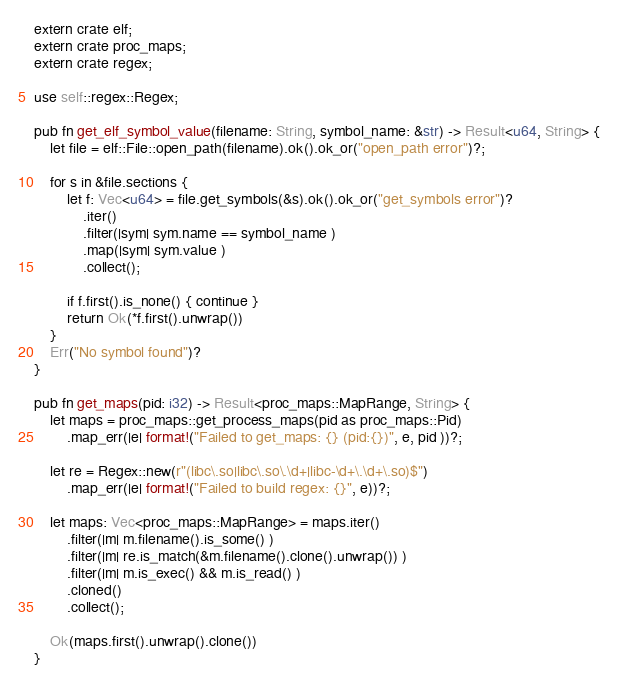<code> <loc_0><loc_0><loc_500><loc_500><_Rust_>extern crate elf;
extern crate proc_maps;
extern crate regex;

use self::regex::Regex;

pub fn get_elf_symbol_value(filename: String, symbol_name: &str) -> Result<u64, String> {
    let file = elf::File::open_path(filename).ok().ok_or("open_path error")?;

    for s in &file.sections {
        let f: Vec<u64> = file.get_symbols(&s).ok().ok_or("get_symbols error")?
            .iter()
            .filter(|sym| sym.name == symbol_name )
            .map(|sym| sym.value )
            .collect();

        if f.first().is_none() { continue }
        return Ok(*f.first().unwrap())
    }
    Err("No symbol found")?
}

pub fn get_maps(pid: i32) -> Result<proc_maps::MapRange, String> {
    let maps = proc_maps::get_process_maps(pid as proc_maps::Pid)
        .map_err(|e| format!("Failed to get_maps: {} (pid:{})", e, pid ))?;

    let re = Regex::new(r"(libc\.so|libc\.so\.\d+|libc-\d+\.\d+\.so)$")
        .map_err(|e| format!("Failed to build regex: {}", e))?;

    let maps: Vec<proc_maps::MapRange> = maps.iter()
        .filter(|m| m.filename().is_some() )
        .filter(|m| re.is_match(&m.filename().clone().unwrap()) )
        .filter(|m| m.is_exec() && m.is_read() )
        .cloned()
        .collect();

    Ok(maps.first().unwrap().clone())
}

</code> 